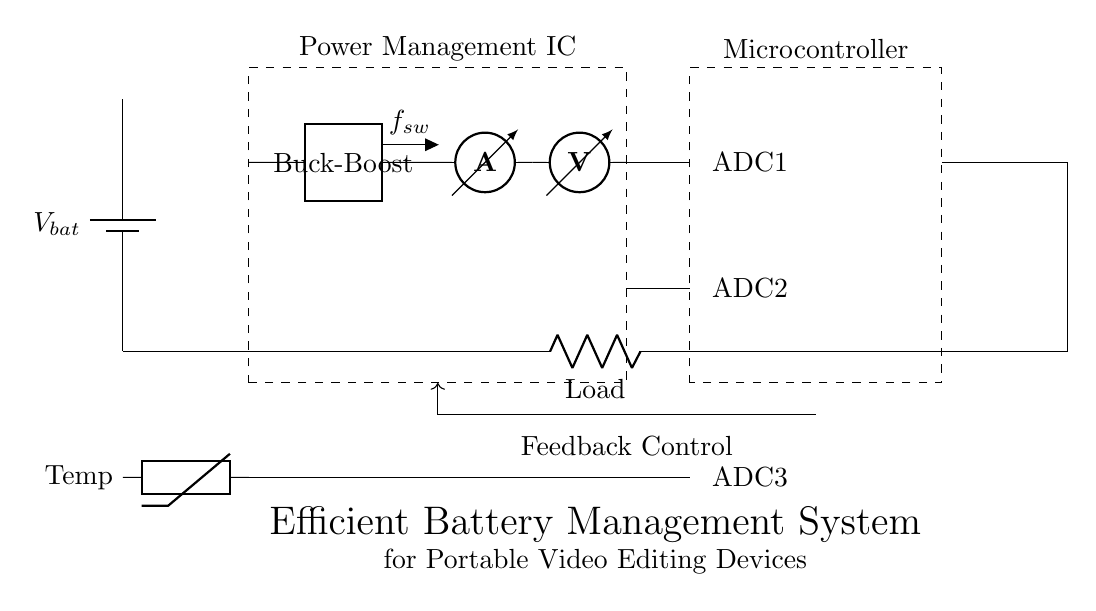What components are present in the circuit? The circuit includes a battery, power management IC, buck-boost converter, ammeter, voltmeter, microcontroller, temperature sensor, and a load. Each of these components serves a specific function, contributing to the overall battery management and power distribution for the video editing device.
Answer: battery, power management IC, buck-boost converter, ammeter, voltmeter, microcontroller, temperature sensor, load What does the power management IC control? The power management IC controls the voltage and current distribution throughout the circuit. It regulates the output to maintain the appropriate levels for the connected components, ensuring efficient use of the battery's energy while powering the video editing device.
Answer: voltage and current distribution What is the function of the buck-boost converter? The buck-boost converter converts the input voltage from the battery to a stable output voltage required by the load. It can step up or step down the voltage as needed, making it versatile for varying battery conditions and load requirements in portable devices.
Answer: convert input voltage How does the feedback control improve system performance? The feedback control loop continuously monitors parameters like voltage and temperature. It adjusts the output accordingly to optimize performance and safety, helping prevent overcharging or excessive discharging of the battery, which can extend its lifespan.
Answer: optimizes performance and safety What are the features monitored by the microcontroller? The microcontroller monitors voltage and current through the ammeter and voltmeter, as well as temperature via the thermistor. This data is essential for managing the battery's health and ensuring the device operates efficiently under various conditions.
Answer: voltage, current, temperature What does the temperature sensor contribute to the battery management system? The temperature sensor provides critical data on the battery's thermal state, which is important for safe operation. Overheating could lead to battery failure or other issues, so monitoring helps adjust charging and discharging rates to prevent overheating.
Answer: ensures safe operation How many ADC inputs are in the microcontroller? The microcontroller has three ADC inputs: one for voltage, one for current, and one for temperature. Each ADC input corresponds to specific measurements vital for the battery management system.
Answer: three ADC inputs 